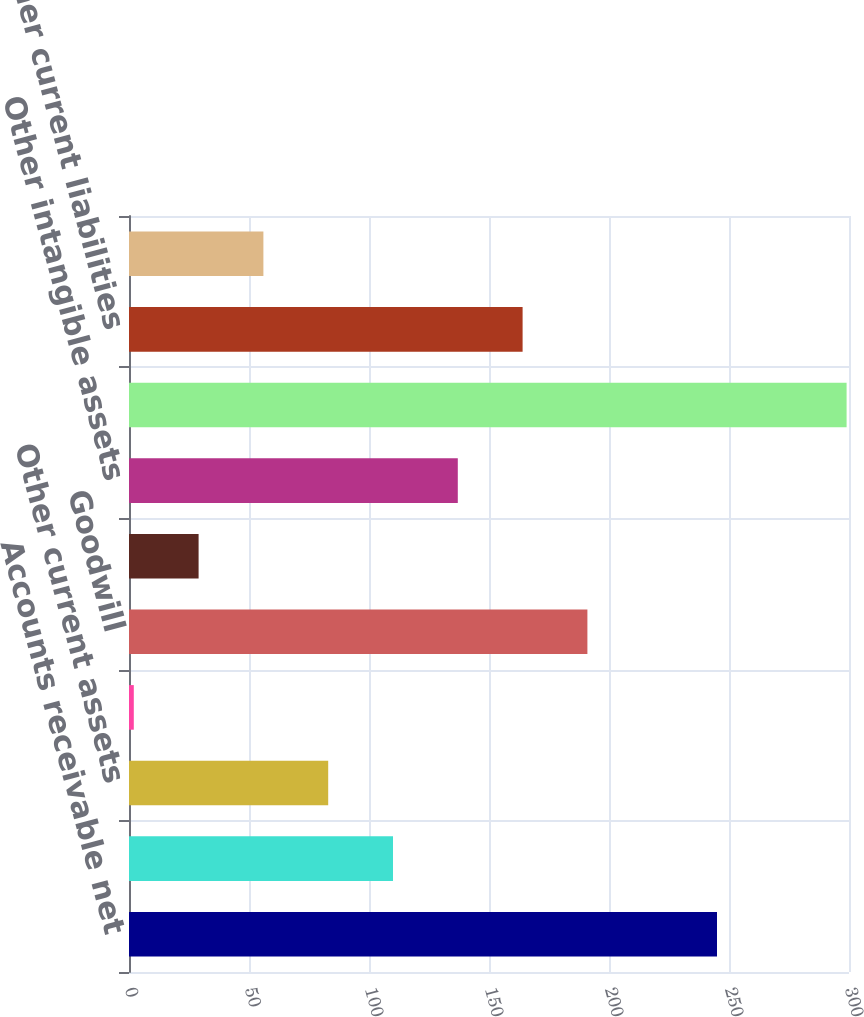<chart> <loc_0><loc_0><loc_500><loc_500><bar_chart><fcel>Accounts receivable net<fcel>Inventory<fcel>Other current assets<fcel>Plants properties and<fcel>Goodwill<fcel>Deferred tax asset<fcel>Other intangible assets<fcel>Total assets acquired<fcel>Other current liabilities<fcel>Other liabilities<nl><fcel>245<fcel>110<fcel>83<fcel>2<fcel>191<fcel>29<fcel>137<fcel>299<fcel>164<fcel>56<nl></chart> 